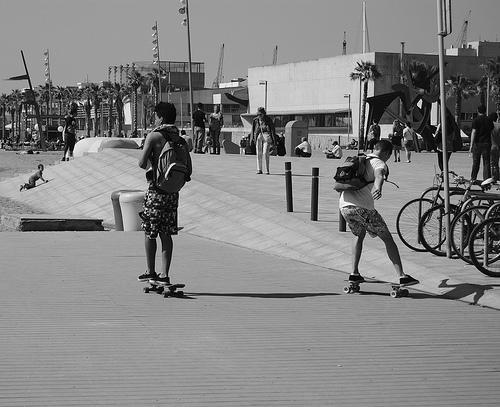How many bikes are in the picture?
Give a very brief answer. 4. 